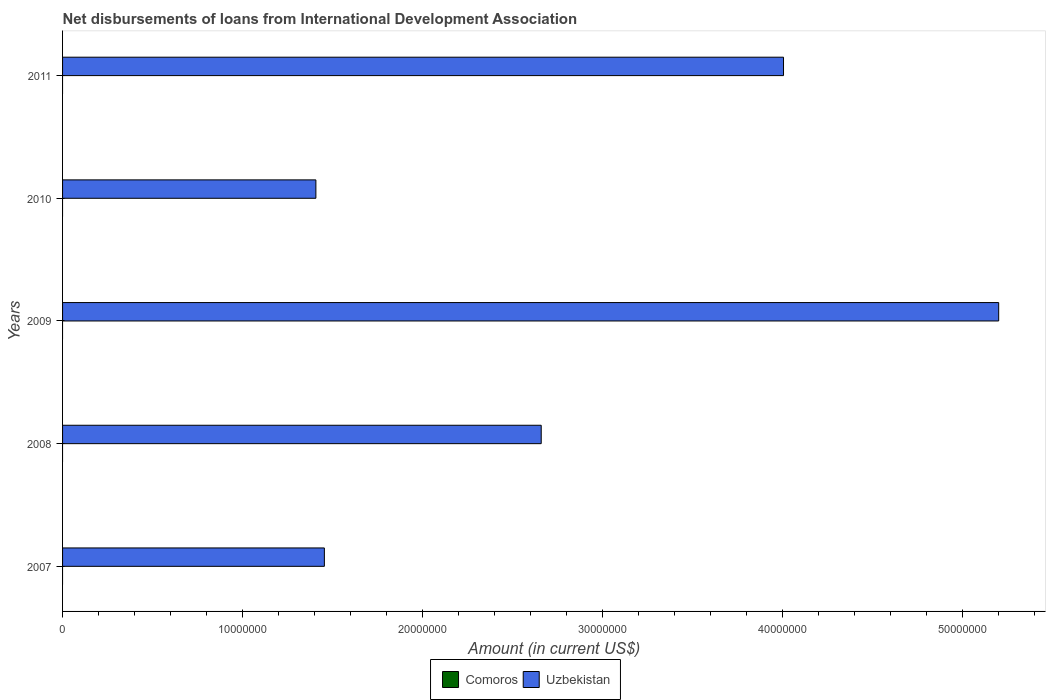How many different coloured bars are there?
Offer a terse response. 1. Are the number of bars on each tick of the Y-axis equal?
Make the answer very short. Yes. What is the label of the 5th group of bars from the top?
Your answer should be very brief. 2007. What is the amount of loans disbursed in Uzbekistan in 2007?
Offer a very short reply. 1.46e+07. Across all years, what is the maximum amount of loans disbursed in Uzbekistan?
Offer a very short reply. 5.20e+07. Across all years, what is the minimum amount of loans disbursed in Comoros?
Ensure brevity in your answer.  0. What is the total amount of loans disbursed in Uzbekistan in the graph?
Your answer should be very brief. 1.47e+08. What is the difference between the amount of loans disbursed in Uzbekistan in 2007 and that in 2011?
Provide a short and direct response. -2.55e+07. What is the difference between the amount of loans disbursed in Uzbekistan in 2009 and the amount of loans disbursed in Comoros in 2011?
Your response must be concise. 5.20e+07. What is the average amount of loans disbursed in Uzbekistan per year?
Your answer should be compact. 2.95e+07. What is the ratio of the amount of loans disbursed in Uzbekistan in 2007 to that in 2010?
Keep it short and to the point. 1.03. Is the amount of loans disbursed in Uzbekistan in 2007 less than that in 2008?
Provide a succinct answer. Yes. What is the difference between the highest and the second highest amount of loans disbursed in Uzbekistan?
Give a very brief answer. 1.20e+07. What is the difference between the highest and the lowest amount of loans disbursed in Uzbekistan?
Your answer should be very brief. 3.80e+07. In how many years, is the amount of loans disbursed in Comoros greater than the average amount of loans disbursed in Comoros taken over all years?
Provide a short and direct response. 0. How many years are there in the graph?
Provide a short and direct response. 5. Are the values on the major ticks of X-axis written in scientific E-notation?
Make the answer very short. No. Where does the legend appear in the graph?
Keep it short and to the point. Bottom center. What is the title of the graph?
Provide a succinct answer. Net disbursements of loans from International Development Association. Does "Afghanistan" appear as one of the legend labels in the graph?
Make the answer very short. No. What is the Amount (in current US$) in Comoros in 2007?
Your response must be concise. 0. What is the Amount (in current US$) of Uzbekistan in 2007?
Offer a very short reply. 1.46e+07. What is the Amount (in current US$) of Comoros in 2008?
Offer a terse response. 0. What is the Amount (in current US$) in Uzbekistan in 2008?
Keep it short and to the point. 2.66e+07. What is the Amount (in current US$) of Uzbekistan in 2009?
Offer a terse response. 5.20e+07. What is the Amount (in current US$) in Uzbekistan in 2010?
Keep it short and to the point. 1.41e+07. What is the Amount (in current US$) in Comoros in 2011?
Offer a very short reply. 0. What is the Amount (in current US$) in Uzbekistan in 2011?
Ensure brevity in your answer.  4.01e+07. Across all years, what is the maximum Amount (in current US$) in Uzbekistan?
Give a very brief answer. 5.20e+07. Across all years, what is the minimum Amount (in current US$) of Uzbekistan?
Provide a short and direct response. 1.41e+07. What is the total Amount (in current US$) in Uzbekistan in the graph?
Keep it short and to the point. 1.47e+08. What is the difference between the Amount (in current US$) of Uzbekistan in 2007 and that in 2008?
Make the answer very short. -1.21e+07. What is the difference between the Amount (in current US$) in Uzbekistan in 2007 and that in 2009?
Make the answer very short. -3.75e+07. What is the difference between the Amount (in current US$) of Uzbekistan in 2007 and that in 2010?
Ensure brevity in your answer.  4.72e+05. What is the difference between the Amount (in current US$) of Uzbekistan in 2007 and that in 2011?
Give a very brief answer. -2.55e+07. What is the difference between the Amount (in current US$) of Uzbekistan in 2008 and that in 2009?
Offer a terse response. -2.54e+07. What is the difference between the Amount (in current US$) of Uzbekistan in 2008 and that in 2010?
Provide a succinct answer. 1.25e+07. What is the difference between the Amount (in current US$) in Uzbekistan in 2008 and that in 2011?
Provide a short and direct response. -1.35e+07. What is the difference between the Amount (in current US$) of Uzbekistan in 2009 and that in 2010?
Keep it short and to the point. 3.80e+07. What is the difference between the Amount (in current US$) in Uzbekistan in 2009 and that in 2011?
Provide a short and direct response. 1.20e+07. What is the difference between the Amount (in current US$) of Uzbekistan in 2010 and that in 2011?
Give a very brief answer. -2.60e+07. What is the average Amount (in current US$) of Uzbekistan per year?
Your response must be concise. 2.95e+07. What is the ratio of the Amount (in current US$) in Uzbekistan in 2007 to that in 2008?
Provide a short and direct response. 0.55. What is the ratio of the Amount (in current US$) in Uzbekistan in 2007 to that in 2009?
Make the answer very short. 0.28. What is the ratio of the Amount (in current US$) in Uzbekistan in 2007 to that in 2010?
Make the answer very short. 1.03. What is the ratio of the Amount (in current US$) in Uzbekistan in 2007 to that in 2011?
Offer a terse response. 0.36. What is the ratio of the Amount (in current US$) of Uzbekistan in 2008 to that in 2009?
Your answer should be very brief. 0.51. What is the ratio of the Amount (in current US$) of Uzbekistan in 2008 to that in 2010?
Offer a very short reply. 1.89. What is the ratio of the Amount (in current US$) of Uzbekistan in 2008 to that in 2011?
Ensure brevity in your answer.  0.66. What is the ratio of the Amount (in current US$) in Uzbekistan in 2009 to that in 2010?
Ensure brevity in your answer.  3.7. What is the ratio of the Amount (in current US$) in Uzbekistan in 2009 to that in 2011?
Provide a short and direct response. 1.3. What is the ratio of the Amount (in current US$) in Uzbekistan in 2010 to that in 2011?
Offer a terse response. 0.35. What is the difference between the highest and the second highest Amount (in current US$) of Uzbekistan?
Give a very brief answer. 1.20e+07. What is the difference between the highest and the lowest Amount (in current US$) in Uzbekistan?
Keep it short and to the point. 3.80e+07. 